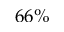<formula> <loc_0><loc_0><loc_500><loc_500>6 6 \%</formula> 